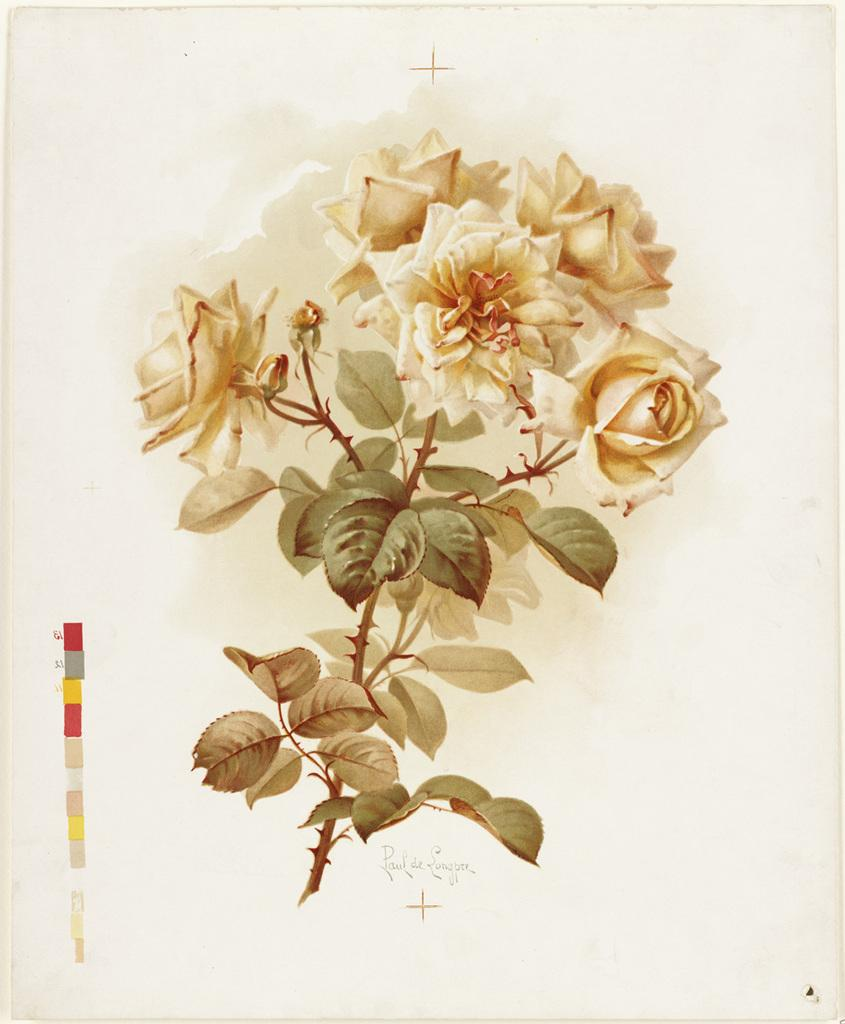What type of plant material can be seen in the image? There are leaves and flowers in the image. Where are the flowers located in the image? The flowers are in the middle of the image. What part of the flowers is visible in the image? The petals of the flowers are visible. What is written or depicted at the bottom of the image? There is text at the bottom of the image. What type of expert advice can be found on the wall in the image? There is no wall or expert advice present in the image; it features leaves, flowers, and text. 